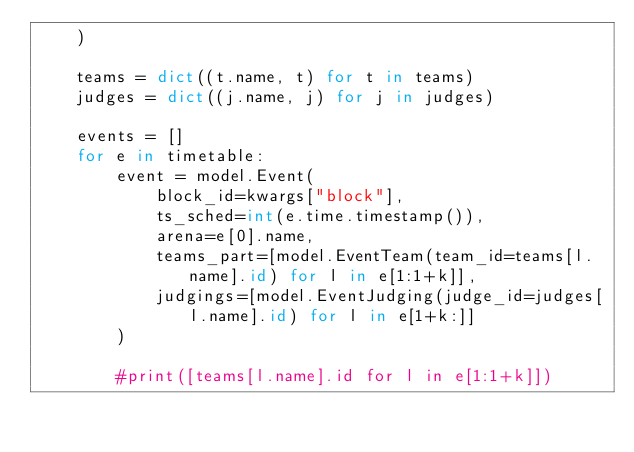Convert code to text. <code><loc_0><loc_0><loc_500><loc_500><_Python_>    )

    teams = dict((t.name, t) for t in teams)
    judges = dict((j.name, j) for j in judges)

    events = []
    for e in timetable:
        event = model.Event(
            block_id=kwargs["block"],
            ts_sched=int(e.time.timestamp()),
            arena=e[0].name,
            teams_part=[model.EventTeam(team_id=teams[l.name].id) for l in e[1:1+k]],
            judgings=[model.EventJudging(judge_id=judges[l.name].id) for l in e[1+k:]]
        )

        #print([teams[l.name].id for l in e[1:1+k]])
</code> 